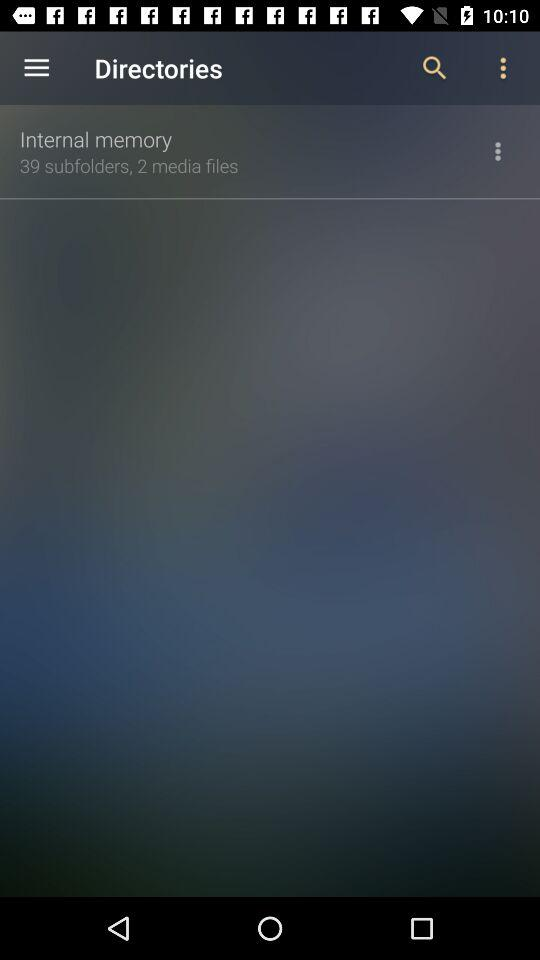How many media files are there in internal memory? There are 2 media files. 